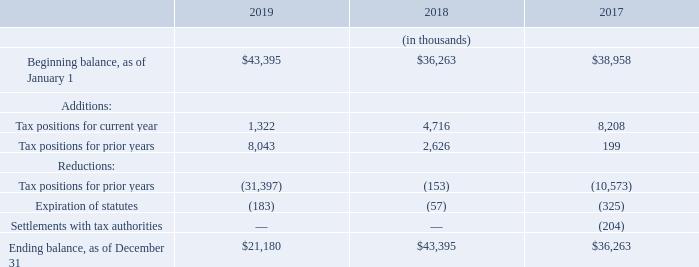Teradyne’s gross unrecognized tax benefits for the years ended December 31, 2019, 2018 and 2017 were as follows:
Current year additions relate to federal and state research credits. Prior year additions primarily relate to stock-based compensation. Prior year reductions are primarily composed of federal and state reserves related to transfer pricing and research credits and resulted from the completion of the 2015 U.S. federal audit in the first quarter of 2019.
Of the $21.2 million of unrecognized tax benefits as of December 31, 2019, $12.7 million would impact the consolidated income tax rate if ultimately recognized. The remaining $8.5 million would impact deferred taxes if recognized.
Teradyne does not anticipate a material change in the balance of unrecognized tax benefits as of December 31, 2019 in the next twelve months.
Teradyne records all interest and penalties related to income taxes as a component of income tax expense. Accrued interest and penalties related to income tax items at December 31, 2019 and 2018 amounted to $1.4 million and $0.3 million, respectively. For the years ended December 31, 2019, 2018 and 2017, expense of $1.1 million, expense of $0.1 million and benefit of $0.1 million, respectively, was recorded for interest and penalties related to income tax items.
Teradyne is subject to U.S. federal income tax, as well as income tax in multiple state, local and foreign jurisdictions. As of December 31, 2019, all material state and local income tax matters have been concluded through 2013, all material federal income tax matters have been concluded through 2015 and all material foreign income tax matters have been concluded through 2011. However, in some jurisdictions, including the United States, operating losses and tax credits may be subject to adjustment until such time as they are utilized and the year of utilization is closed to adjustment.
As of December 31, 2019, Teradyne is not permanently reinvested with respect to the unremitted earnings of non-U.S. subsidiaries to the extent that those earnings exceed local statutory and operational requirements. Remittance of those earnings is not expected to result in material income tax.
What do Prior year additions primarily relate to? Stock-based compensation. What do Current year additions relate to? Federal and state research credits. In which years was Teradyne’s gross unrecognized tax benefits calculated? 2019, 2018, 2017. In which year was the Ending balance, as of December 31 the largest? 43,395>36,263>21,180
Answer: 2018. What was the change in Beginning balance, as of January 1 in 2019 from 2018?
Answer scale should be: thousand. 43,395-36,263
Answer: 7132. What was the percentage change in Beginning balance, as of January 1 in 2019 from 2018?
Answer scale should be: percent. (43,395-36,263)/36,263
Answer: 19.67. 